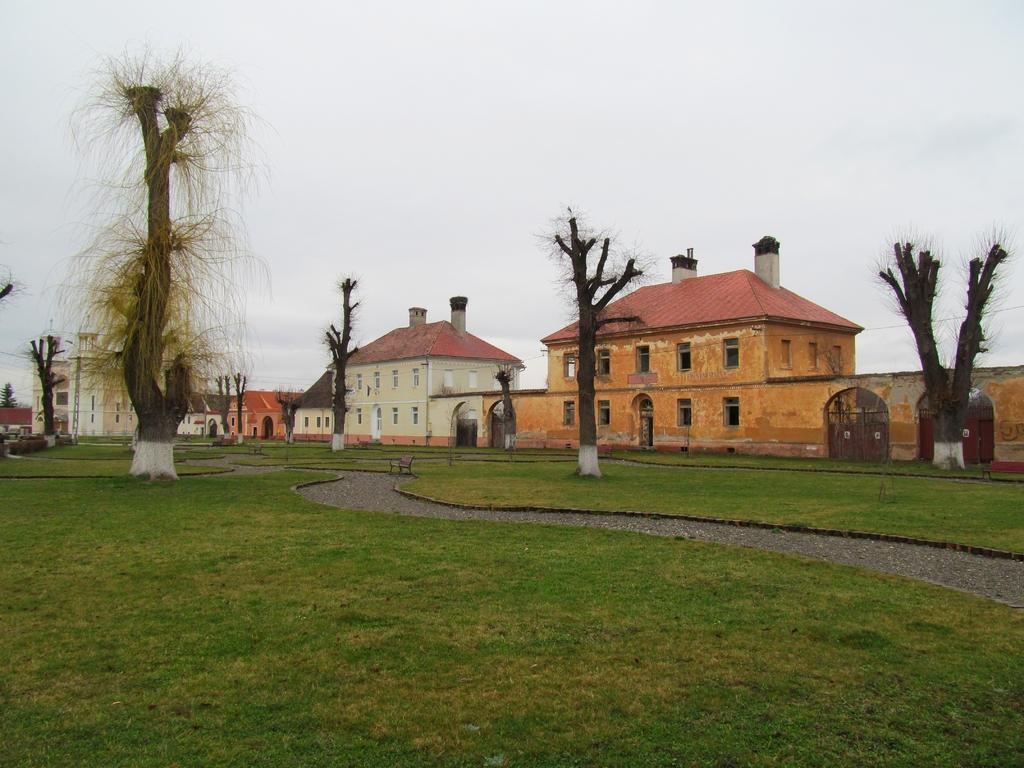What type of terrain is visible in the foreground of the image? There is grass and a road in the foreground of the image. What structures can be seen in the middle of the image? There are houses in the middle of the image. What is visible at the top of the image? The sky is visible at the top of the image. Where is the cemetery located in the image? There is no cemetery present in the image. Can you see any water bodies, such as a lake, in the image? There is no lake visible in the image. 